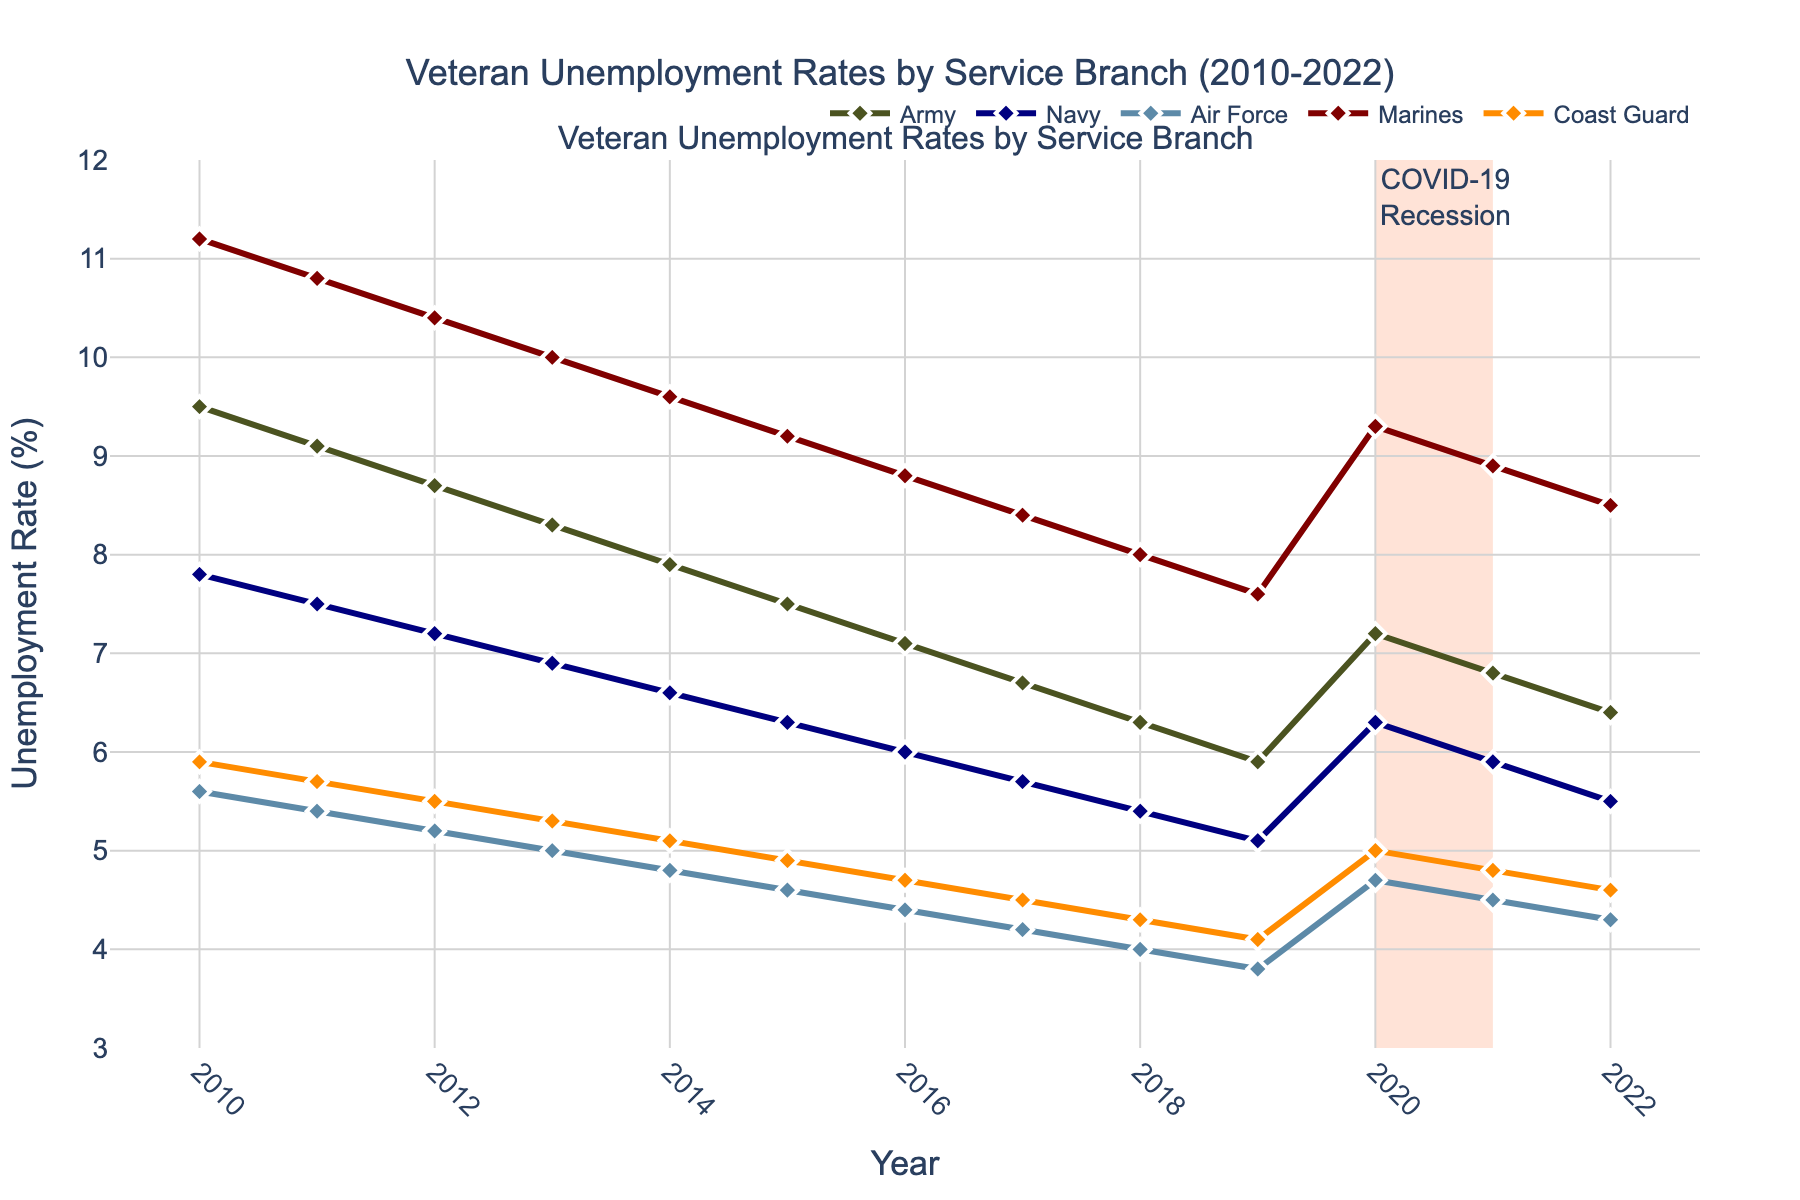What is the unemployment rate trend for the Army from 2010 to 2022? The unemployment rate for the Army starts at 9.5% in 2010 and shows a general decreasing trend, reaching 6.4% in 2022. This indicates a steady improvement in unemployment rates for Army veterans over the years.
Answer: Decreasing trend Which service branch had the highest unemployment rate in 2010? In 2010, the Marines had the highest unemployment rate at 11.2%, which is greater than the unemployment rates of the Army (9.5%), Navy (7.8%), Air Force (5.6%), and Coast Guard (5.9%).
Answer: Marines What is the average unemployment rate for the Coast Guard from 2010 to 2022? First, sum the Coast Guard unemployment rates for each year from 2010 to 2022: 5.9 + 5.7 + 5.5 + 5.3 + 5.1 + 4.9 + 4.7 + 4.5 + 4.3 + 4.1 + 5.0 + 4.8 + 4.6 = 60.4. Then, divide by the number of years (13) to get the average: 60.4 / 13 = 4.65.
Answer: 4.65% In which year did the Navy experience its lowest unemployment rate? By examining the line for the Navy, its lowest unemployment rate occurred in 2019 at 5.1%.
Answer: 2019 How did the unemployment rate for the Air Force change during the COVID-19 recession (2020-2021)? In 2020, the unemployment rate for the Air Force was 4.7%. In 2021, it decreased slightly to 4.5%. This indicates a marginal decrease during the COVID-19 recession.
Answer: Decreased slightly Compare the unemployment rates of the Army and the Marines in 2015. Which was higher and by how much? In 2015, the unemployment rate for the Army was 7.5%, and for the Marines, it was 9.2%. The rate for the Marines was higher by 9.2% - 7.5% = 1.7%.
Answer: Marines by 1.7% Which branch showed the most significant decrease in unemployment rate from 2010 to 2022? Calculate the difference in unemployment rates for each branch from 2010 to 2022. Army: 9.5 - 6.4 = 3.1, Navy: 7.8 - 5.5 = 2.3, Air Force: 5.6 - 4.3 = 1.3, Marines: 11.2 - 8.5 = 2.7, Coast Guard: 5.9 - 4.6 = 1.3. The Army showed the most significant decrease of 3.1 percentage points.
Answer: Army What is the unemployment rate trend for the Air Force from 2010 to 2019? The unemployment rate for the Air Force starts at 5.6% in 2010 and generally decreases each year, reaching 3.8% in 2019, showing a steady downward trend over the decade.
Answer: Decreasing trend Which year saw the highest overall unemployment rate among all branches? In 2010, the Marines had the highest rate at 11.2%. All other branches had their highest rates below 11.2% during the years covered.
Answer: 2010 What visual elements indicate a significant external event affecting employment rates, and which years does it cover? The figure includes a shaded area labeled "COVID-19 Recession" from 2020 to 2021. This section indicates a significant external event affecting unemployment rates.
Answer: Shaded area 2020-2021 